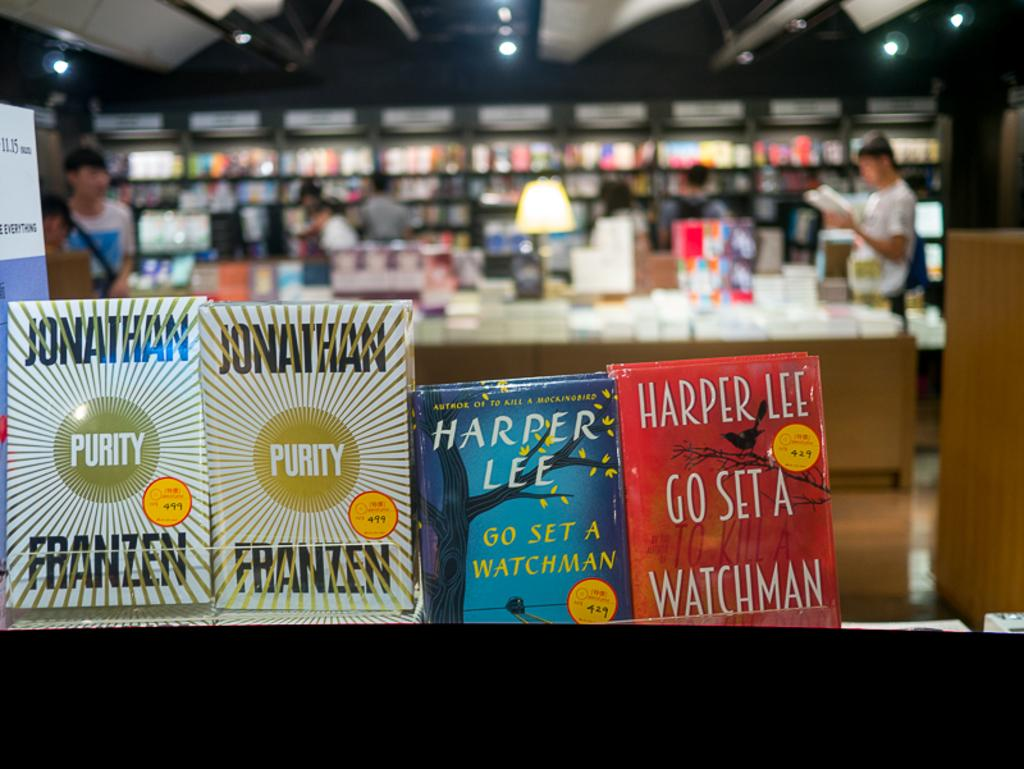<image>
Describe the image concisely. Books by Harper Lee and Jonathan Franzen are on display at a book store. 